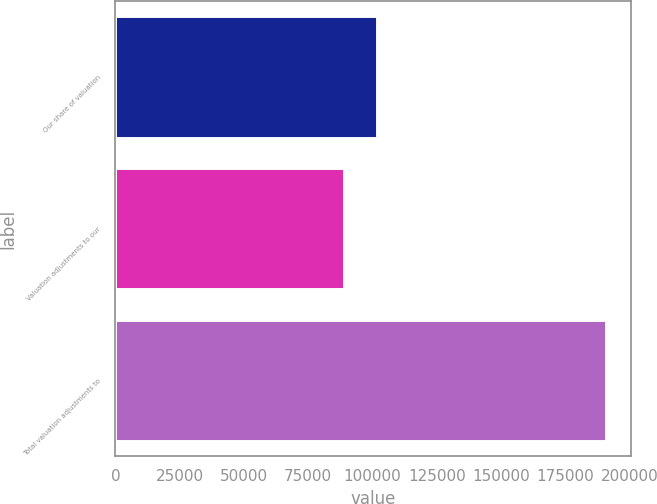Convert chart to OTSL. <chart><loc_0><loc_0><loc_500><loc_500><bar_chart><fcel>Our share of valuation<fcel>Valuation adjustments to our<fcel>Total valuation adjustments to<nl><fcel>101893<fcel>88972<fcel>190865<nl></chart> 